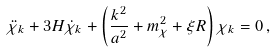<formula> <loc_0><loc_0><loc_500><loc_500>\ddot { \chi } _ { k } + 3 H \dot { \chi } _ { k } + \left ( \frac { k ^ { 2 } } { a ^ { 2 } } + m _ { \chi } ^ { 2 } + \xi R \right ) \chi _ { k } = 0 \, ,</formula> 